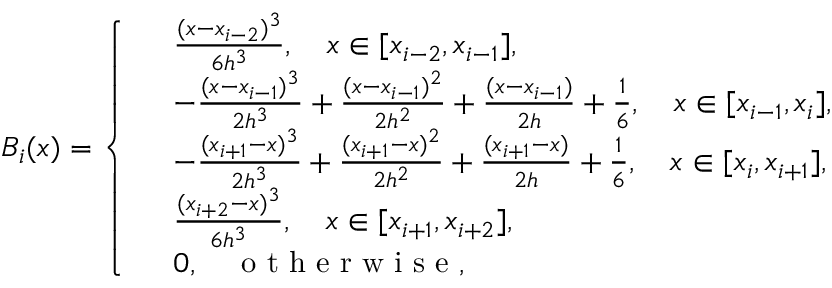<formula> <loc_0><loc_0><loc_500><loc_500>B _ { i } ( x ) = \left \{ \begin{array} { r l } & { \frac { ( x - x _ { i - 2 } ) ^ { 3 } } { 6 h ^ { 3 } } , \quad x \in [ x _ { i - 2 } , x _ { i - 1 } ] , } \\ & { - \frac { ( x - x _ { i - 1 } ) ^ { 3 } } { 2 h ^ { 3 } } + \frac { ( x - x _ { i - 1 } ) ^ { 2 } } { 2 h ^ { 2 } } + \frac { ( x - x _ { i - 1 } ) } { 2 h } + \frac { 1 } { 6 } , \quad x \in [ x _ { i - 1 } , x _ { i } ] , } \\ & { - \frac { ( x _ { i + 1 } - x ) ^ { 3 } } { 2 h ^ { 3 } } + \frac { ( x _ { i + 1 } - x ) ^ { 2 } } { 2 h ^ { 2 } } + \frac { ( x _ { i + 1 } - x ) } { 2 h } + \frac { 1 } { 6 } , \quad x \in [ x _ { i } , x _ { i + 1 } ] , } \\ & { \frac { ( x _ { i + 2 } - x ) ^ { 3 } } { 6 h ^ { 3 } } , \quad x \in [ x _ { i + 1 } , x _ { i + 2 } ] , } \\ & { 0 , \quad o t h e r w i s e , } \end{array}</formula> 